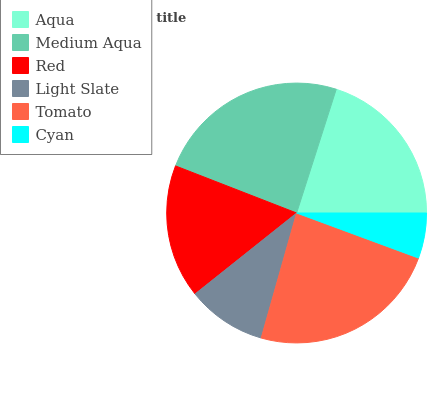Is Cyan the minimum?
Answer yes or no. Yes. Is Medium Aqua the maximum?
Answer yes or no. Yes. Is Red the minimum?
Answer yes or no. No. Is Red the maximum?
Answer yes or no. No. Is Medium Aqua greater than Red?
Answer yes or no. Yes. Is Red less than Medium Aqua?
Answer yes or no. Yes. Is Red greater than Medium Aqua?
Answer yes or no. No. Is Medium Aqua less than Red?
Answer yes or no. No. Is Aqua the high median?
Answer yes or no. Yes. Is Red the low median?
Answer yes or no. Yes. Is Red the high median?
Answer yes or no. No. Is Medium Aqua the low median?
Answer yes or no. No. 